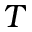<formula> <loc_0><loc_0><loc_500><loc_500>T</formula> 